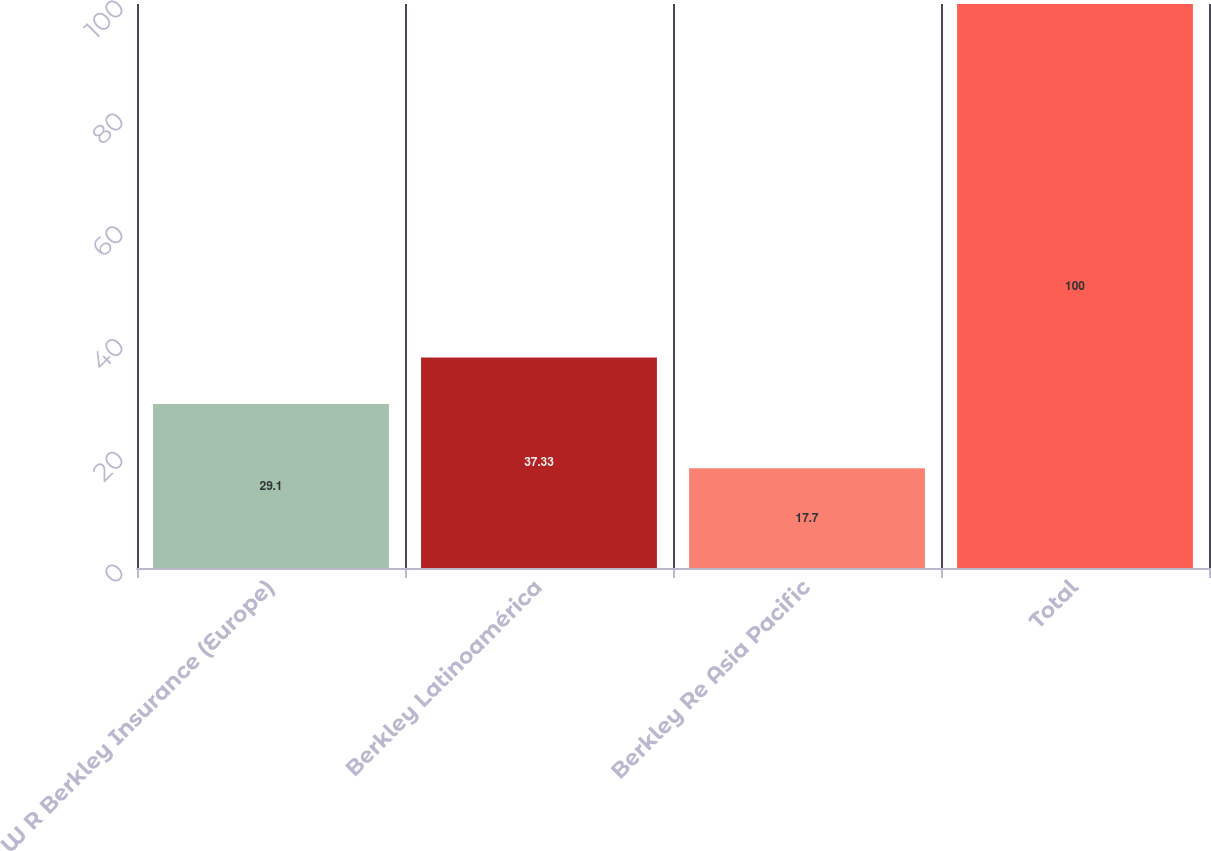Convert chart. <chart><loc_0><loc_0><loc_500><loc_500><bar_chart><fcel>W R Berkley Insurance (Europe)<fcel>Berkley Latinoamérica<fcel>Berkley Re Asia Pacific<fcel>Total<nl><fcel>29.1<fcel>37.33<fcel>17.7<fcel>100<nl></chart> 